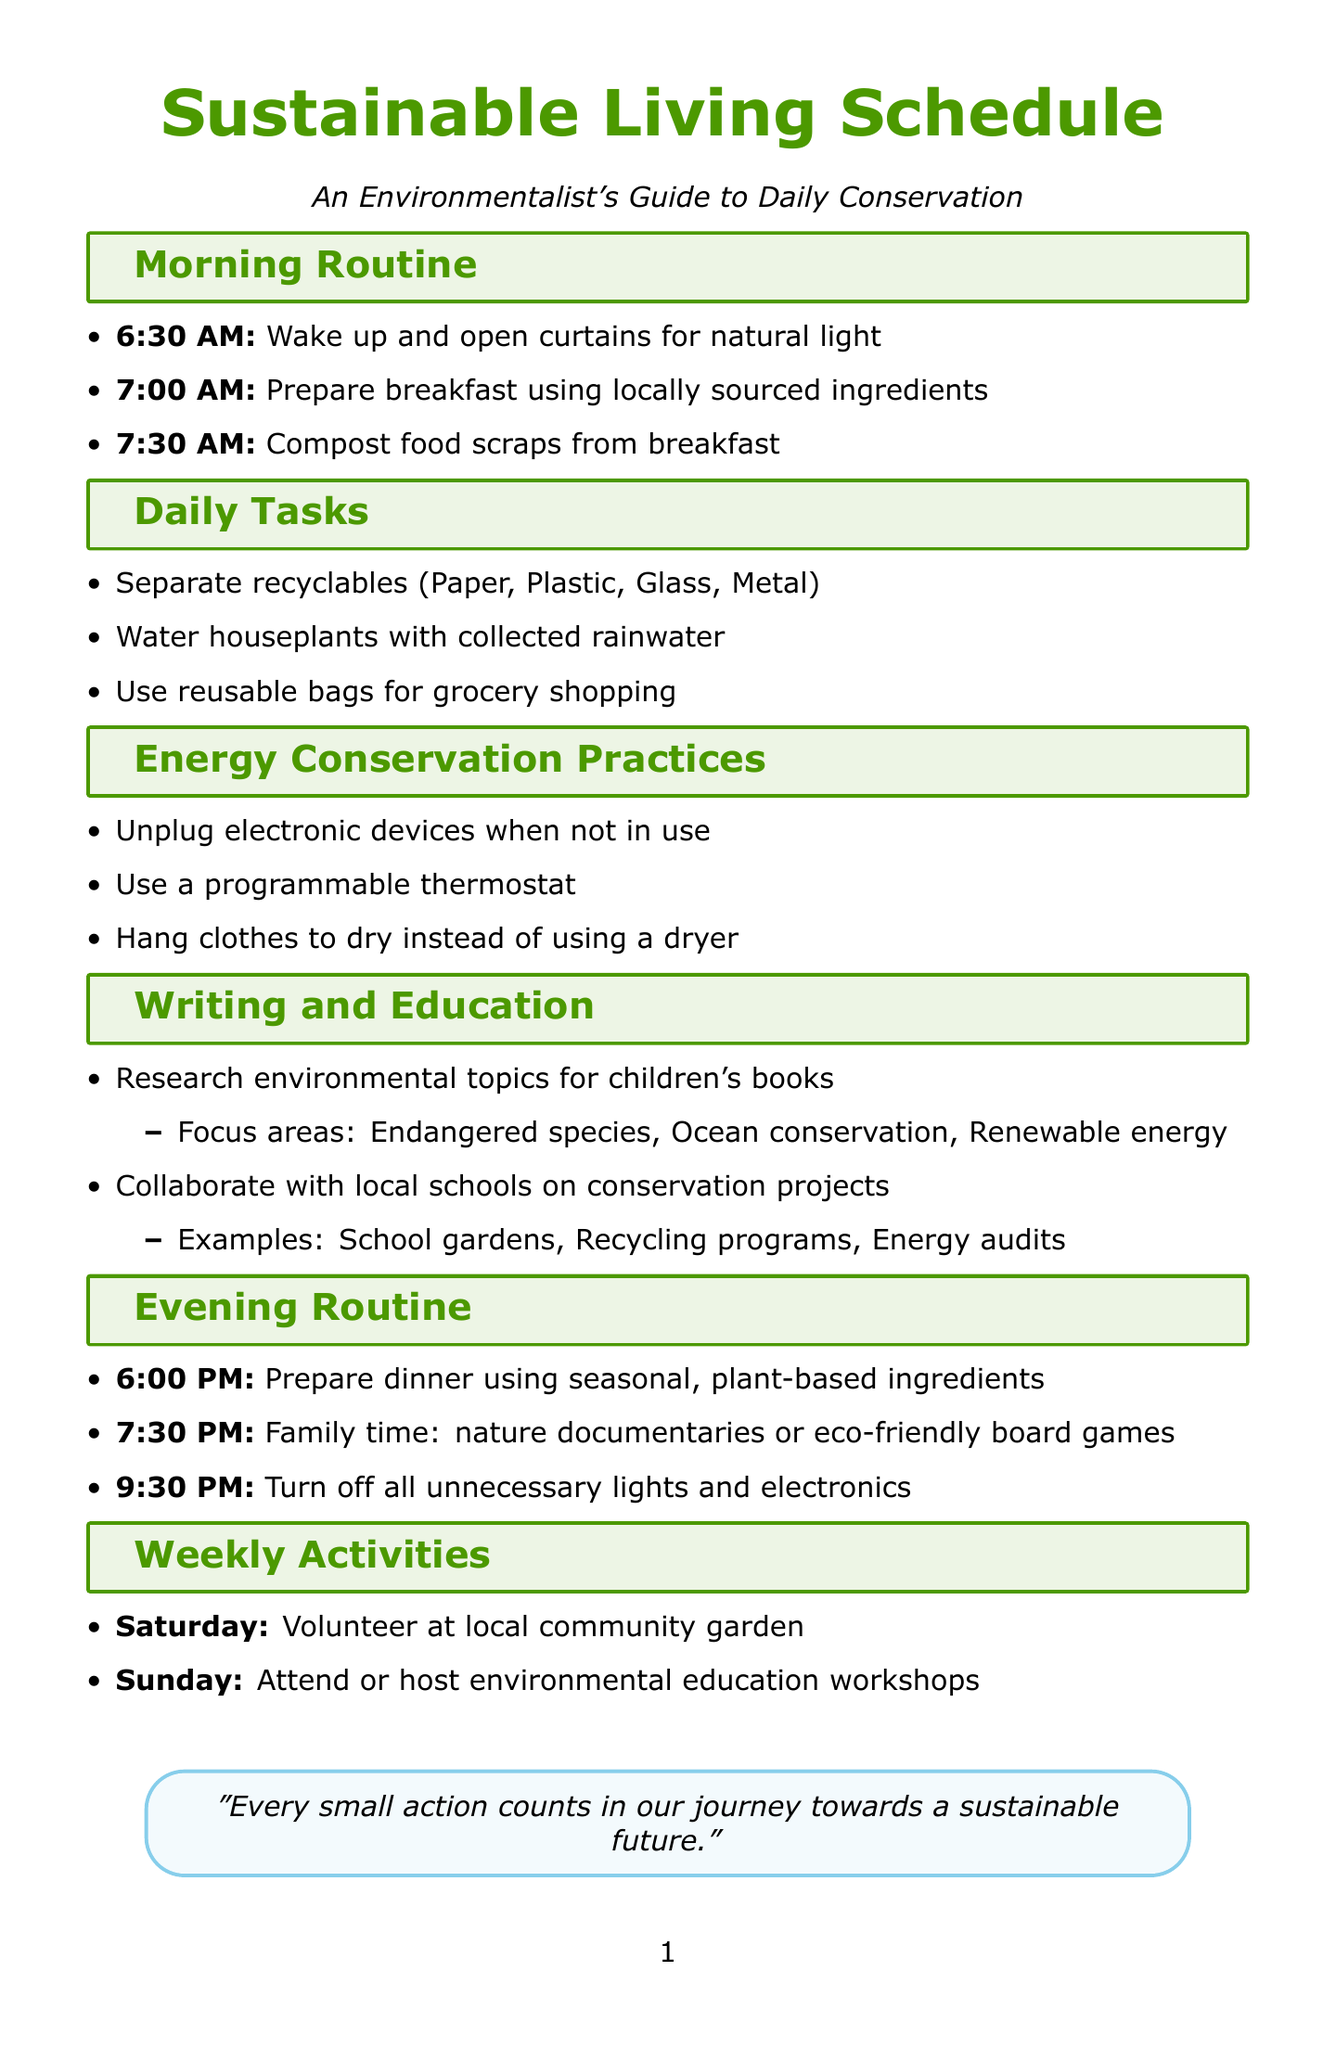What time does the morning routine start? The morning routine starts at 6:30 AM, as indicated in the section.
Answer: 6:30 AM What materials are separated for recycling? The document lists four materials that should be separated for recycling in the daily tasks.
Answer: Paper, Plastic, Glass, Metal What is the sustainability aspect of watering houseplants with collected rainwater? The document specifies that this practice conserves water and reduces reliance on treated water.
Answer: Water conservation How does preparing dinner with seasonal ingredients benefit sustainability? The document states that using seasonal, plant-based ingredients reduces carbon footprint and supports sustainable agriculture.
Answer: Reducing carbon footprint What practice is recommended for energy conservation related to electronic devices? The document mentions unplugging electronic devices when not in use to save energy.
Answer: Unplug devices How often should one volunteer at the local community garden according to the weekly activities? The schedule specifies volunteering at the community garden every Saturday.
Answer: Saturday What time is designated for family activities in the evening routine? The document provides a specific time of 7:30 PM for family time activities.
Answer: 7:30 PM What are focus areas for research in children's books mentioned in the document? The focus areas include endangered species, ocean conservation, and renewable energy.
Answer: Endangered species, Ocean conservation, Renewable energy What activity is planned for Sundays in the weekly activities? The document indicates that Sundays are designated for attending or hosting environmental education workshops.
Answer: Environmental education workshops 